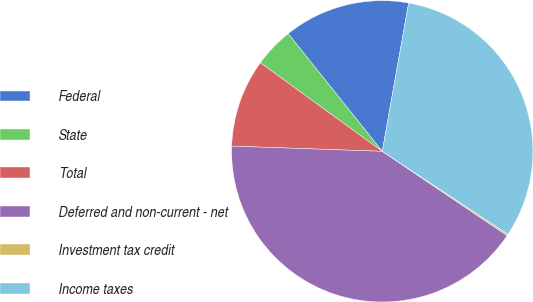Convert chart to OTSL. <chart><loc_0><loc_0><loc_500><loc_500><pie_chart><fcel>Federal<fcel>State<fcel>Total<fcel>Deferred and non-current - net<fcel>Investment tax credit<fcel>Income taxes<nl><fcel>13.54%<fcel>4.26%<fcel>9.45%<fcel>41.1%<fcel>0.17%<fcel>31.48%<nl></chart> 